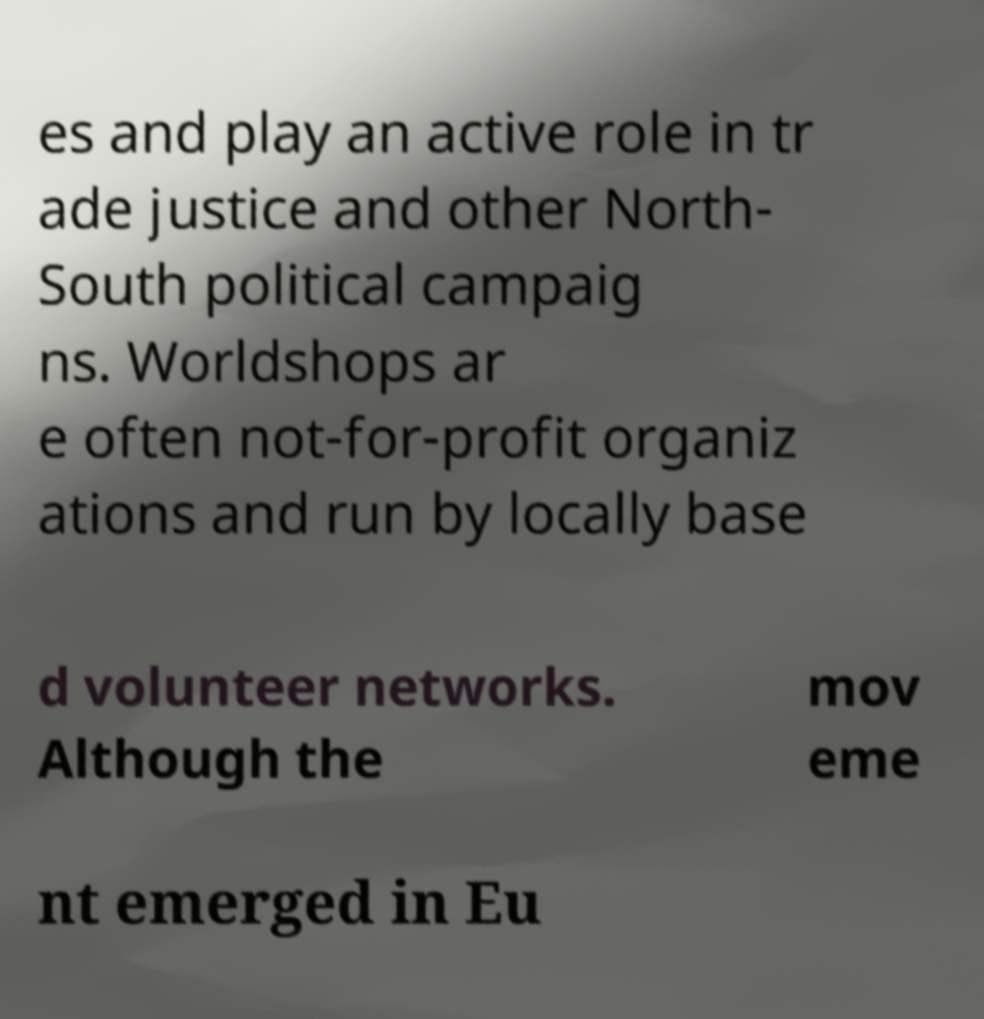Please identify and transcribe the text found in this image. es and play an active role in tr ade justice and other North- South political campaig ns. Worldshops ar e often not-for-profit organiz ations and run by locally base d volunteer networks. Although the mov eme nt emerged in Eu 